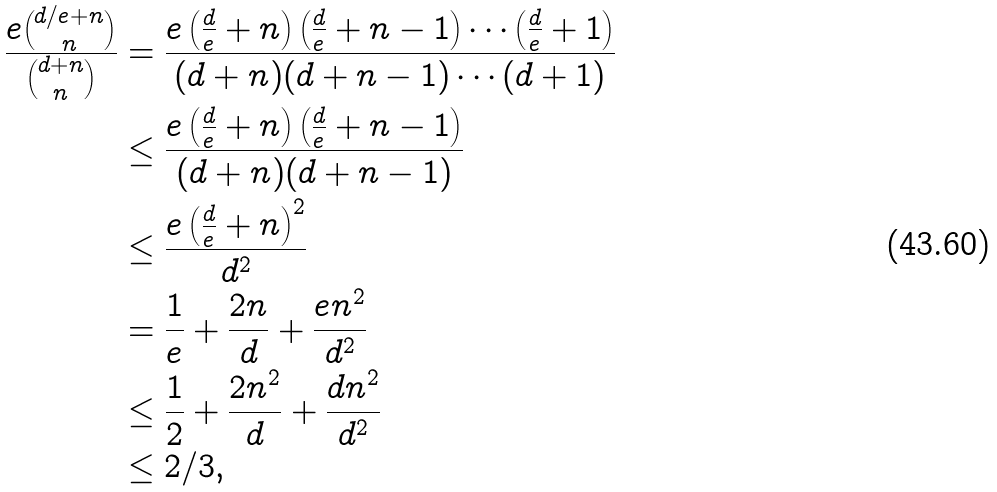<formula> <loc_0><loc_0><loc_500><loc_500>\frac { e \binom { d / e + n } { n } } { \binom { d + n } { n } } & = \frac { e \left ( \frac { d } { e } + n \right ) \left ( \frac { d } { e } + n - 1 \right ) \cdots \left ( \frac { d } { e } + 1 \right ) } { ( d + n ) ( d + n - 1 ) \cdots ( d + 1 ) } \\ & \leq \frac { e \left ( \frac { d } { e } + n \right ) \left ( \frac { d } { e } + n - 1 \right ) } { ( d + n ) ( d + n - 1 ) } \\ & \leq \frac { e \left ( \frac { d } { e } + n \right ) ^ { 2 } } { d ^ { 2 } } \\ & = \frac { 1 } { e } + \frac { 2 n } { d } + \frac { e n ^ { 2 } } { d ^ { 2 } } \\ & \leq \frac { 1 } { 2 } + \frac { 2 n ^ { 2 } } { d } + \frac { d n ^ { 2 } } { d ^ { 2 } } \\ & \leq 2 / 3 ,</formula> 